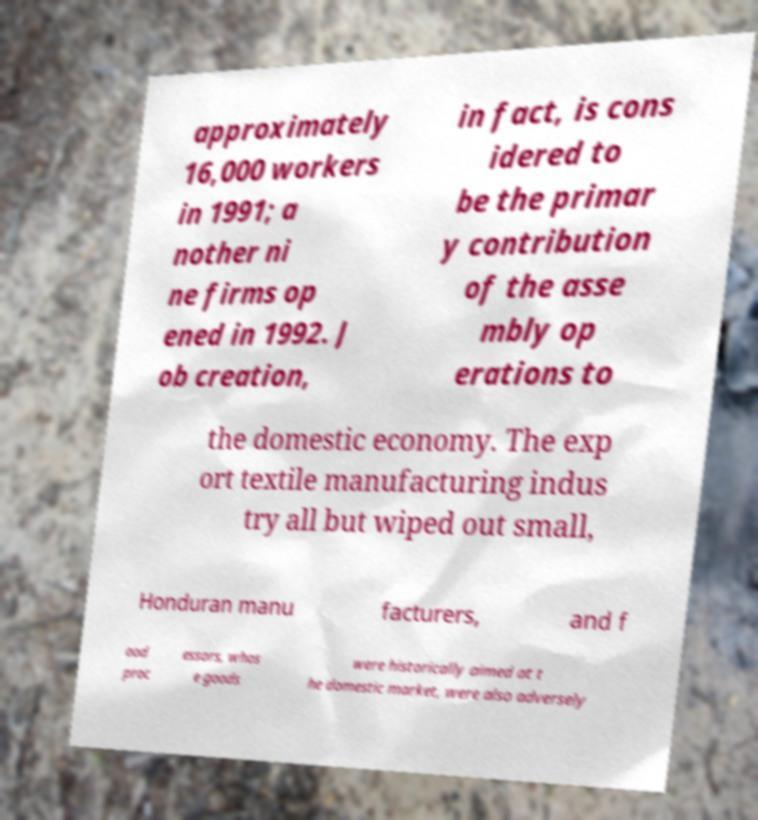I need the written content from this picture converted into text. Can you do that? approximately 16,000 workers in 1991; a nother ni ne firms op ened in 1992. J ob creation, in fact, is cons idered to be the primar y contribution of the asse mbly op erations to the domestic economy. The exp ort textile manufacturing indus try all but wiped out small, Honduran manu facturers, and f ood proc essors, whos e goods were historically aimed at t he domestic market, were also adversely 